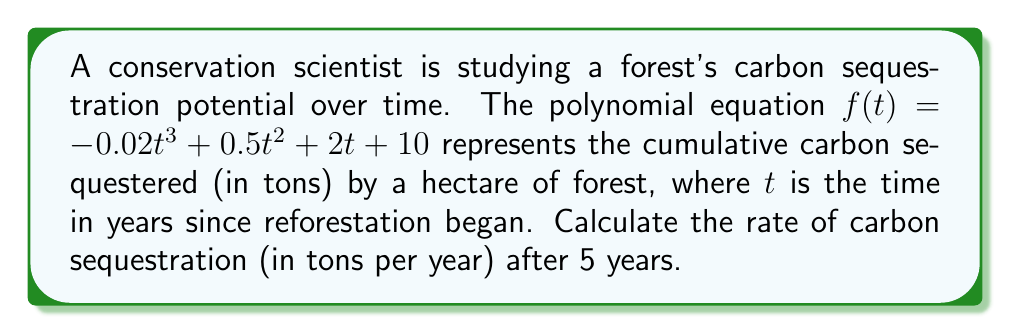Can you solve this math problem? To find the rate of carbon sequestration at a specific time, we need to find the derivative of the given function $f(t)$.

1. Start with the original function:
   $f(t) = -0.02t^3 + 0.5t^2 + 2t + 10$

2. Take the derivative of each term:
   - For $-0.02t^3$: $\frac{d}{dt}(-0.02t^3) = -0.06t^2$
   - For $0.5t^2$: $\frac{d}{dt}(0.5t^2) = t$
   - For $2t$: $\frac{d}{dt}(2t) = 2$
   - For $10$: $\frac{d}{dt}(10) = 0$

3. Combine the terms to get the derivative function:
   $f'(t) = -0.06t^2 + t + 2$

4. This derivative function $f'(t)$ represents the rate of carbon sequestration at any given time $t$.

5. To find the rate after 5 years, substitute $t = 5$ into $f'(t)$:
   $f'(5) = -0.06(5^2) + 5 + 2$
   $= -0.06(25) + 5 + 2$
   $= -1.5 + 5 + 2$
   $= 5.5$

Therefore, the rate of carbon sequestration after 5 years is 5.5 tons per year.
Answer: 5.5 tons/year 